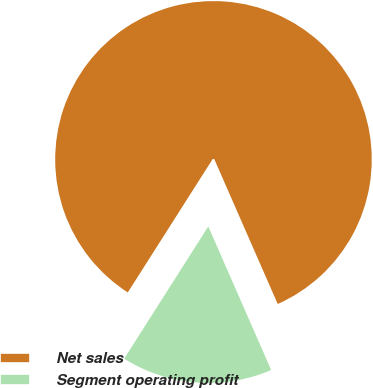Convert chart to OTSL. <chart><loc_0><loc_0><loc_500><loc_500><pie_chart><fcel>Net sales<fcel>Segment operating profit<nl><fcel>84.41%<fcel>15.59%<nl></chart> 